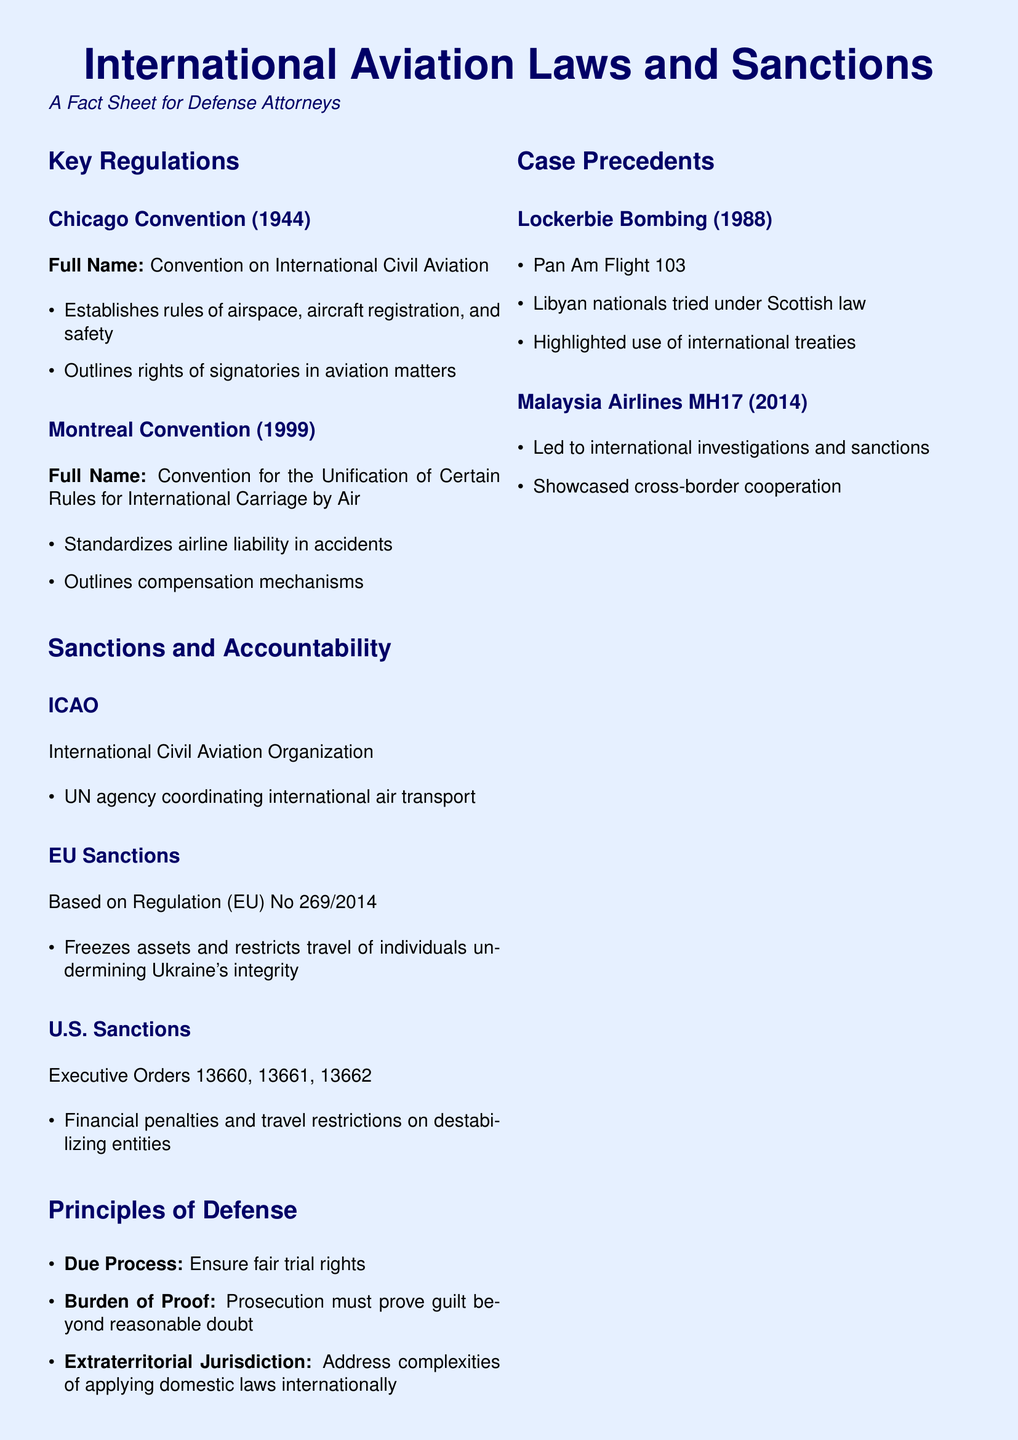What is the full name of the Chicago Convention? The Chicago Convention is also known as the Convention on International Civil Aviation, which is mentioned in the key regulations section of the document.
Answer: Convention on International Civil Aviation What does EU Regulation No 269/2014 do? This regulation is referenced in the sanctions section and relates to freezing assets and restricting travel for individuals impacting Ukraine's integrity.
Answer: Freezes assets and restricts travel What year was the Montreal Convention established? The year of establishment for the Montreal Convention is noted in the key regulations section of the document.
Answer: 1999 Which case involved Libyan nationals tried under Scottish law? The document discusses case precedents and specifically details the Lockerbie Bombing case.
Answer: Lockerbie Bombing What is a key principle of defense highlighted in the document? The principles of defense list multiple key points, including due process, which is crucial for defense attorneys.
Answer: Due Process How many executive orders relate to U.S. sanctions mentioned in the document? The document specifies three executive orders linked to U.S. sanctions.
Answer: Three What 2014 incident led to international investigations? The Malaysia Airlines MH17 incident is mentioned in context with global investigations and sanctions.
Answer: Malaysia Airlines MH17 What organization is responsible for coordinating international air transport? The International Civil Aviation Organization (ICAO) is identified in the document's sanction section.
Answer: International Civil Aviation Organization What should defense attorneys emphasize according to the document? The key takeaways section discusses important considerations for defense attorneys, including emphasizing due process rights.
Answer: Due process rights 